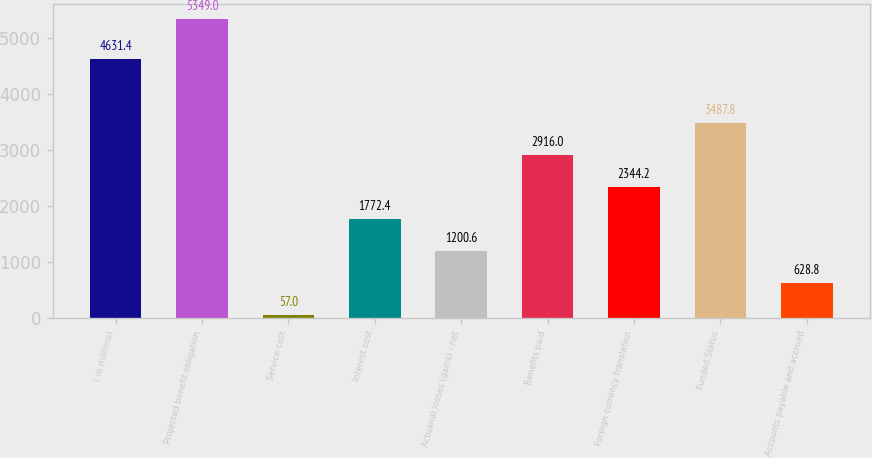Convert chart to OTSL. <chart><loc_0><loc_0><loc_500><loc_500><bar_chart><fcel>( in millions)<fcel>Projected benefit obligation<fcel>Service cost<fcel>Interest cost<fcel>Actuarial losses (gains) - net<fcel>Benefits paid<fcel>Foreign currency translation<fcel>Funded Status<fcel>Accounts payable and accrued<nl><fcel>4631.4<fcel>5349<fcel>57<fcel>1772.4<fcel>1200.6<fcel>2916<fcel>2344.2<fcel>3487.8<fcel>628.8<nl></chart> 